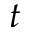<formula> <loc_0><loc_0><loc_500><loc_500>t</formula> 